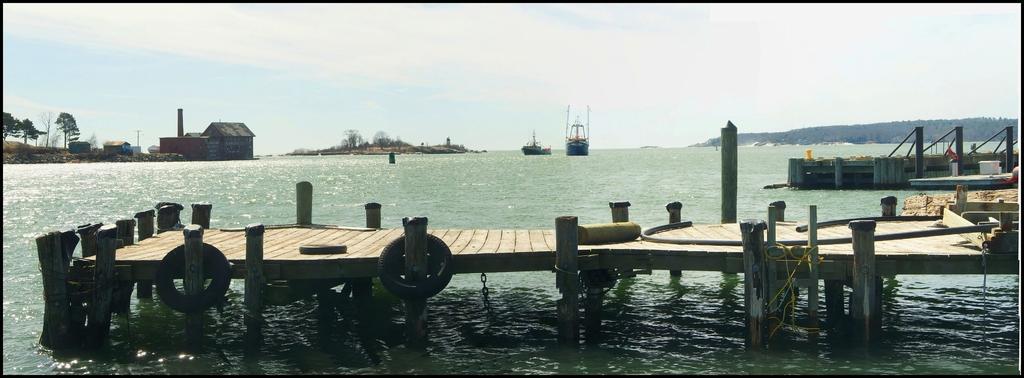Could you give a brief overview of what you see in this image? In this picture we can see water at the bottom, there is a bridge in the middle, we can see two boats in the water, on the left side there are houses and trees, we can see tyres in the front, on the right side there is a pipe, we can see the sky at the top of the picture. 